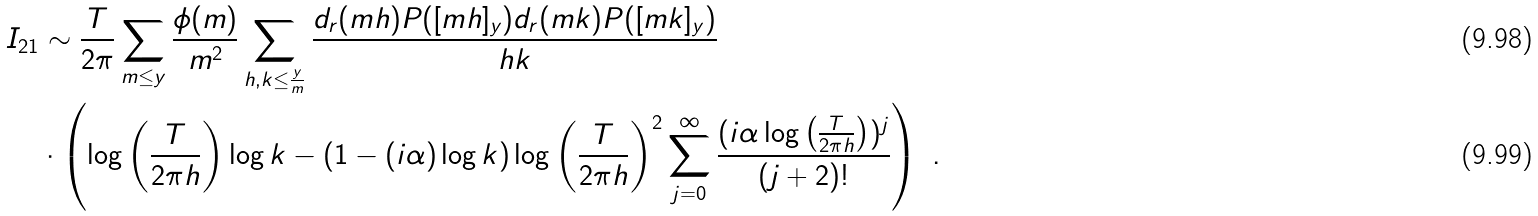Convert formula to latex. <formula><loc_0><loc_0><loc_500><loc_500>I _ { 2 1 } & \sim \frac { T } { 2 \pi } \sum _ { m \leq y } \frac { \phi ( m ) } { m ^ { 2 } } \sum _ { h , k \leq \frac { y } { m } } \frac { d _ { r } ( m h ) P ( [ m h ] _ { y } ) d _ { r } ( m k ) P ( [ m k ] _ { y } ) } { h k } \\ & \cdot \left ( \log \left ( \frac { T } { 2 \pi h } \right ) \log k - ( 1 - ( i \alpha ) \log k ) \log \left ( \frac { T } { 2 \pi h } \right ) ^ { 2 } \sum _ { j = 0 } ^ { \infty } \frac { ( i \alpha \log \left ( \frac { T } { 2 \pi h } \right ) ) ^ { j } } { ( j + 2 ) ! } \right ) \ .</formula> 